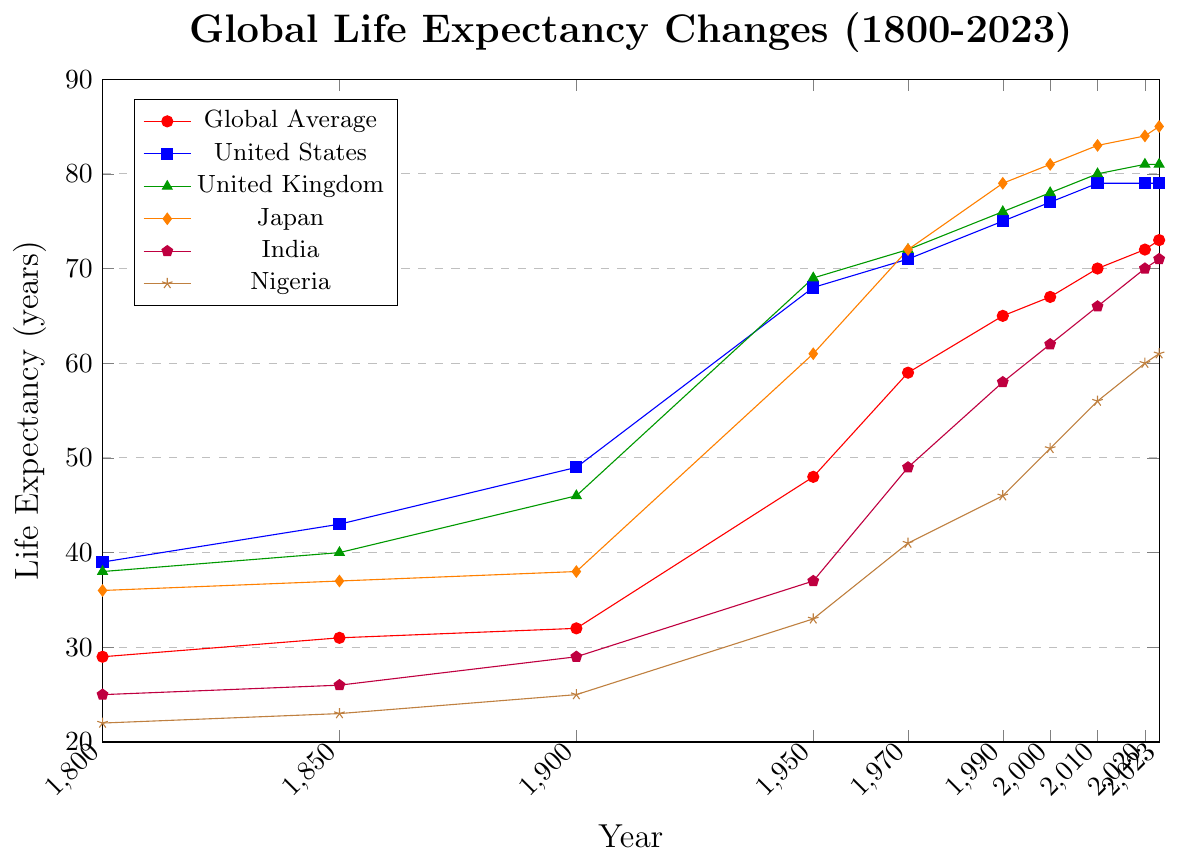Who had the highest life expectancy in 1950? In the plot, locate the year 1950 on the x-axis and look for the highest y-axis point among all lines. The peak value is for the United Kingdom at 69 years.
Answer: United Kingdom Between which years did Global Average life expectancy see the most substantial increase? Compare the changes between consecutive x-values (years) on the Global Average line. The most significant increase is from 1900 to 1950, where it jumped from 32 to 48 years.
Answer: 1900 to 1950 What was the life expectancy difference between Nigeria and the United States in 2020? Locate the year 2020 on the x-axis and find the corresponding y-values for Nigeria (60 years) and the United States (79 years). Subtract Nigeria's value from the United States' value: 79 - 60 = 19 years.
Answer: 19 years Which country showed the least improvement in life expectancy from 1800 to 2023? Subtract the earliest year (1800) from the latest year (2023) for each country, and compare the differences. Nigeria had the least improvement, from 22 to 61 years, a change of 39 years.
Answer: Nigeria How many years did it take for Japan's life expectancy to increase from 38 to 83 years? First, identify the years corresponding to these life expectancy values. Japan had 38 years in 1900 and 83 years in 2010. The time span is 2010 - 1900 = 110 years.
Answer: 110 years By how much did India's life expectancy increase from 1970 to 1990? Locate the life expectancy values for India in 1970 (49 years) and 1990 (58 years). Subtract the earlier value from the later one: 58 - 49 = 9 years.
Answer: 9 years Which country’s life expectancy overtook that of the United Kingdom first, and by which year? Examine when Japan's line first crosses the United Kingdom's line. It occurs around 1990 when Japan's life expectancy (79 years) surpasses the United Kingdom's (76 years).
Answer: Japan, by 1990 